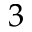Convert formula to latex. <formula><loc_0><loc_0><loc_500><loc_500>3</formula> 